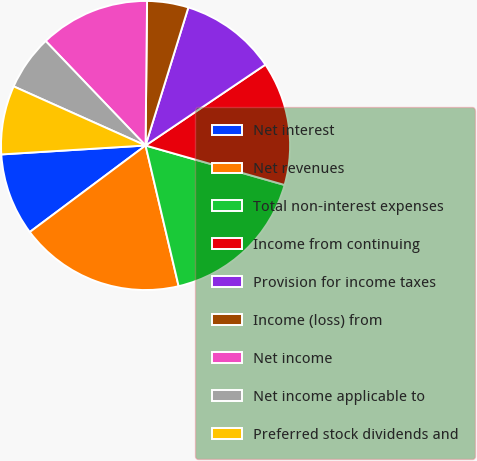<chart> <loc_0><loc_0><loc_500><loc_500><pie_chart><fcel>Net interest<fcel>Net revenues<fcel>Total non-interest expenses<fcel>Income from continuing<fcel>Provision for income taxes<fcel>Income (loss) from<fcel>Net income<fcel>Net income applicable to<fcel>Preferred stock dividends and<nl><fcel>9.23%<fcel>18.46%<fcel>16.92%<fcel>13.85%<fcel>10.77%<fcel>4.62%<fcel>12.31%<fcel>6.15%<fcel>7.69%<nl></chart> 